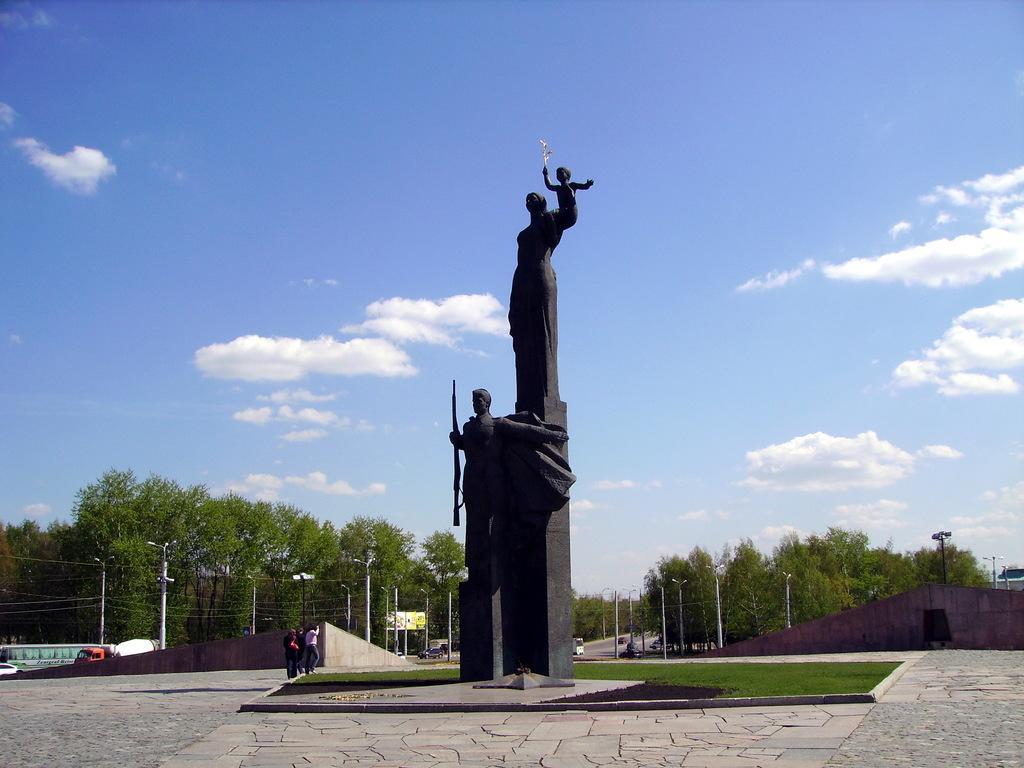How would you summarize this image in a sentence or two? In this picture we can see statues in the middle, on the left side there are three persons and two vehicles, in the background there are some trees, poles, lights and wires, we can see grass at the bottom, there is the sky and clouds at the top of the picture. 